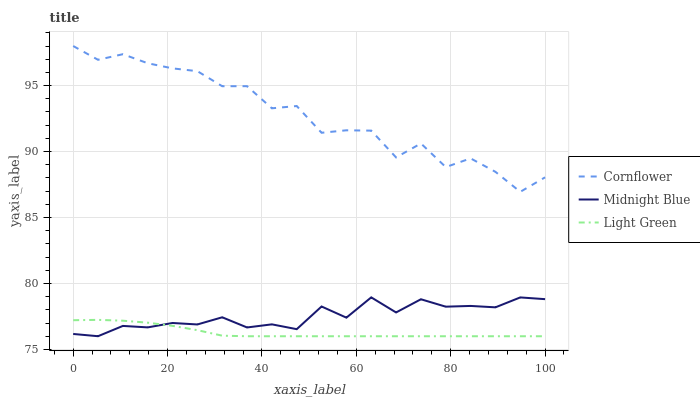Does Light Green have the minimum area under the curve?
Answer yes or no. Yes. Does Cornflower have the maximum area under the curve?
Answer yes or no. Yes. Does Midnight Blue have the minimum area under the curve?
Answer yes or no. No. Does Midnight Blue have the maximum area under the curve?
Answer yes or no. No. Is Light Green the smoothest?
Answer yes or no. Yes. Is Cornflower the roughest?
Answer yes or no. Yes. Is Midnight Blue the smoothest?
Answer yes or no. No. Is Midnight Blue the roughest?
Answer yes or no. No. Does Light Green have the lowest value?
Answer yes or no. Yes. Does Midnight Blue have the lowest value?
Answer yes or no. No. Does Cornflower have the highest value?
Answer yes or no. Yes. Does Midnight Blue have the highest value?
Answer yes or no. No. Is Midnight Blue less than Cornflower?
Answer yes or no. Yes. Is Cornflower greater than Midnight Blue?
Answer yes or no. Yes. Does Light Green intersect Midnight Blue?
Answer yes or no. Yes. Is Light Green less than Midnight Blue?
Answer yes or no. No. Is Light Green greater than Midnight Blue?
Answer yes or no. No. Does Midnight Blue intersect Cornflower?
Answer yes or no. No. 